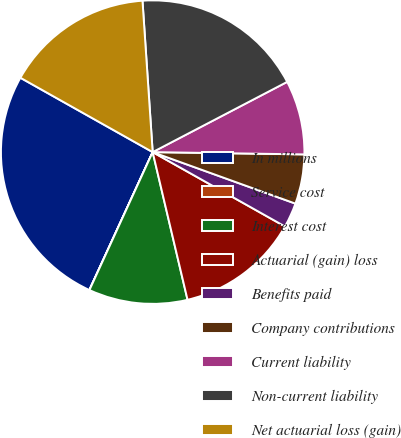<chart> <loc_0><loc_0><loc_500><loc_500><pie_chart><fcel>In millions<fcel>Service cost<fcel>Interest cost<fcel>Actuarial (gain) loss<fcel>Benefits paid<fcel>Company contributions<fcel>Current liability<fcel>Non-current liability<fcel>Net actuarial loss (gain)<nl><fcel>26.3%<fcel>0.01%<fcel>10.53%<fcel>13.16%<fcel>2.64%<fcel>5.27%<fcel>7.9%<fcel>18.41%<fcel>15.78%<nl></chart> 